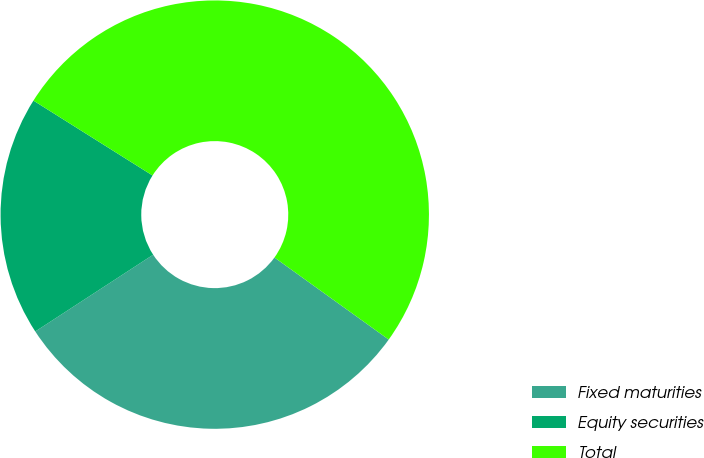Convert chart to OTSL. <chart><loc_0><loc_0><loc_500><loc_500><pie_chart><fcel>Fixed maturities<fcel>Equity securities<fcel>Total<nl><fcel>30.9%<fcel>18.12%<fcel>50.98%<nl></chart> 